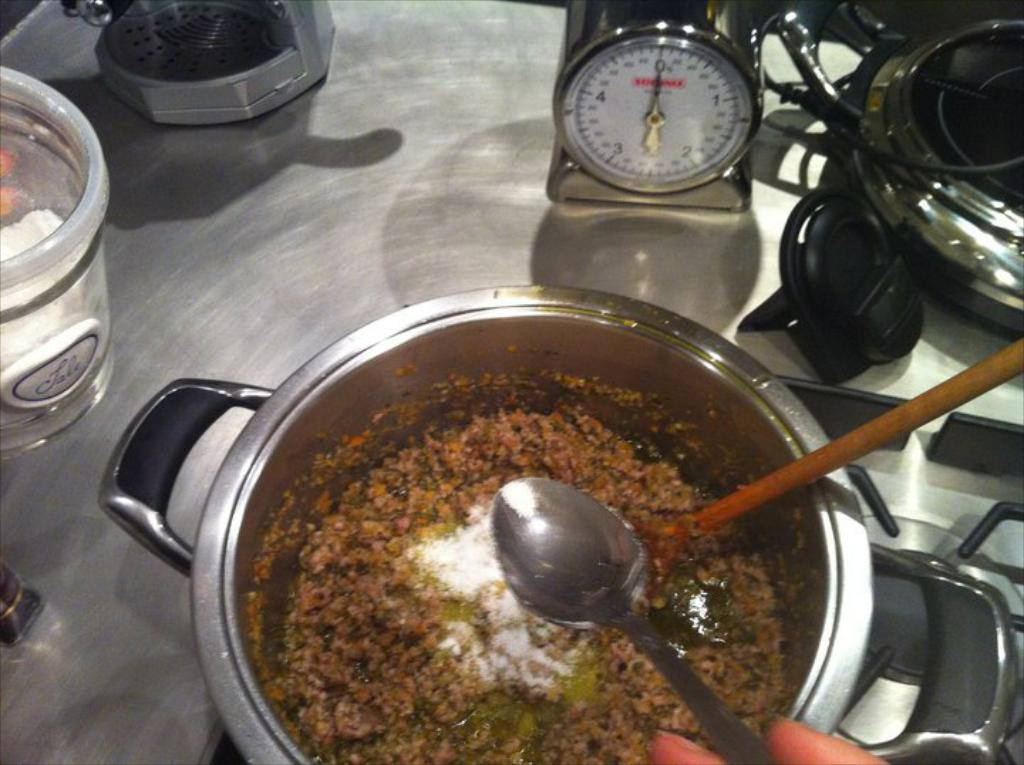What type of items can be seen in the image? There are food items in the image. What utensils are present with the food items? There are spoons in an object in the image. What material is the surface where the other objects are placed? There are other objects on a metal surface in the image. How many girls are present in the image? There is no mention of girls in the image, so it is not possible to determine their presence or number. 